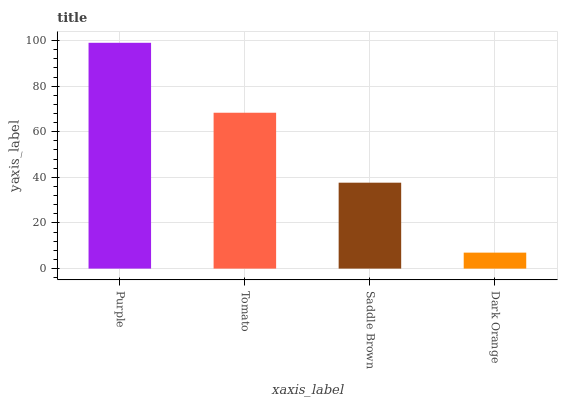Is Dark Orange the minimum?
Answer yes or no. Yes. Is Purple the maximum?
Answer yes or no. Yes. Is Tomato the minimum?
Answer yes or no. No. Is Tomato the maximum?
Answer yes or no. No. Is Purple greater than Tomato?
Answer yes or no. Yes. Is Tomato less than Purple?
Answer yes or no. Yes. Is Tomato greater than Purple?
Answer yes or no. No. Is Purple less than Tomato?
Answer yes or no. No. Is Tomato the high median?
Answer yes or no. Yes. Is Saddle Brown the low median?
Answer yes or no. Yes. Is Saddle Brown the high median?
Answer yes or no. No. Is Tomato the low median?
Answer yes or no. No. 